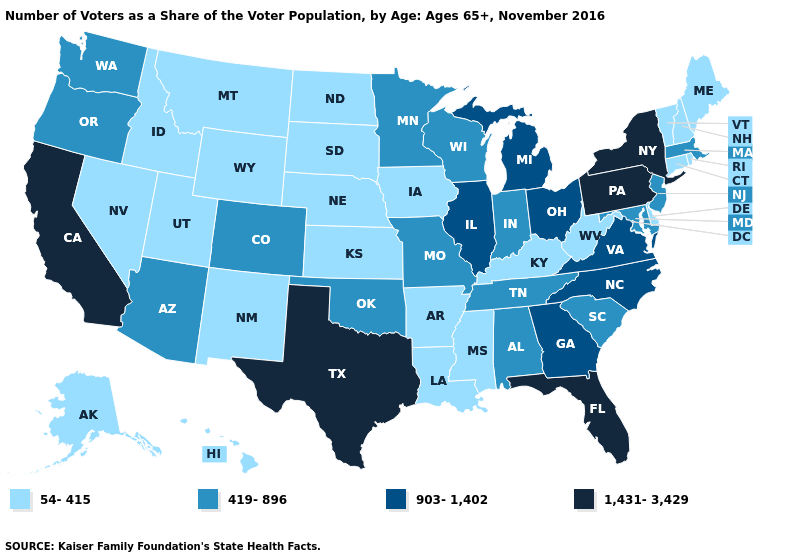What is the lowest value in states that border Utah?
Quick response, please. 54-415. Among the states that border South Dakota , does Iowa have the lowest value?
Keep it brief. Yes. What is the lowest value in states that border Illinois?
Short answer required. 54-415. Which states have the highest value in the USA?
Short answer required. California, Florida, New York, Pennsylvania, Texas. Does the first symbol in the legend represent the smallest category?
Answer briefly. Yes. What is the value of Idaho?
Short answer required. 54-415. Does New York have the highest value in the USA?
Be succinct. Yes. What is the highest value in the USA?
Concise answer only. 1,431-3,429. Which states have the highest value in the USA?
Write a very short answer. California, Florida, New York, Pennsylvania, Texas. What is the lowest value in states that border Massachusetts?
Write a very short answer. 54-415. Which states hav the highest value in the South?
Concise answer only. Florida, Texas. Name the states that have a value in the range 1,431-3,429?
Keep it brief. California, Florida, New York, Pennsylvania, Texas. What is the value of Montana?
Quick response, please. 54-415. Does Colorado have the highest value in the USA?
Keep it brief. No. Among the states that border Arizona , does Utah have the highest value?
Keep it brief. No. 